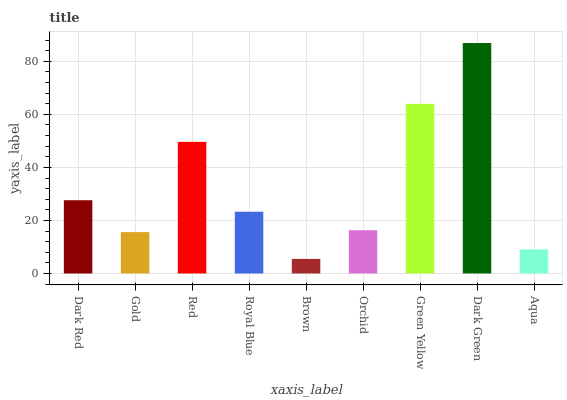Is Brown the minimum?
Answer yes or no. Yes. Is Dark Green the maximum?
Answer yes or no. Yes. Is Gold the minimum?
Answer yes or no. No. Is Gold the maximum?
Answer yes or no. No. Is Dark Red greater than Gold?
Answer yes or no. Yes. Is Gold less than Dark Red?
Answer yes or no. Yes. Is Gold greater than Dark Red?
Answer yes or no. No. Is Dark Red less than Gold?
Answer yes or no. No. Is Royal Blue the high median?
Answer yes or no. Yes. Is Royal Blue the low median?
Answer yes or no. Yes. Is Dark Green the high median?
Answer yes or no. No. Is Gold the low median?
Answer yes or no. No. 